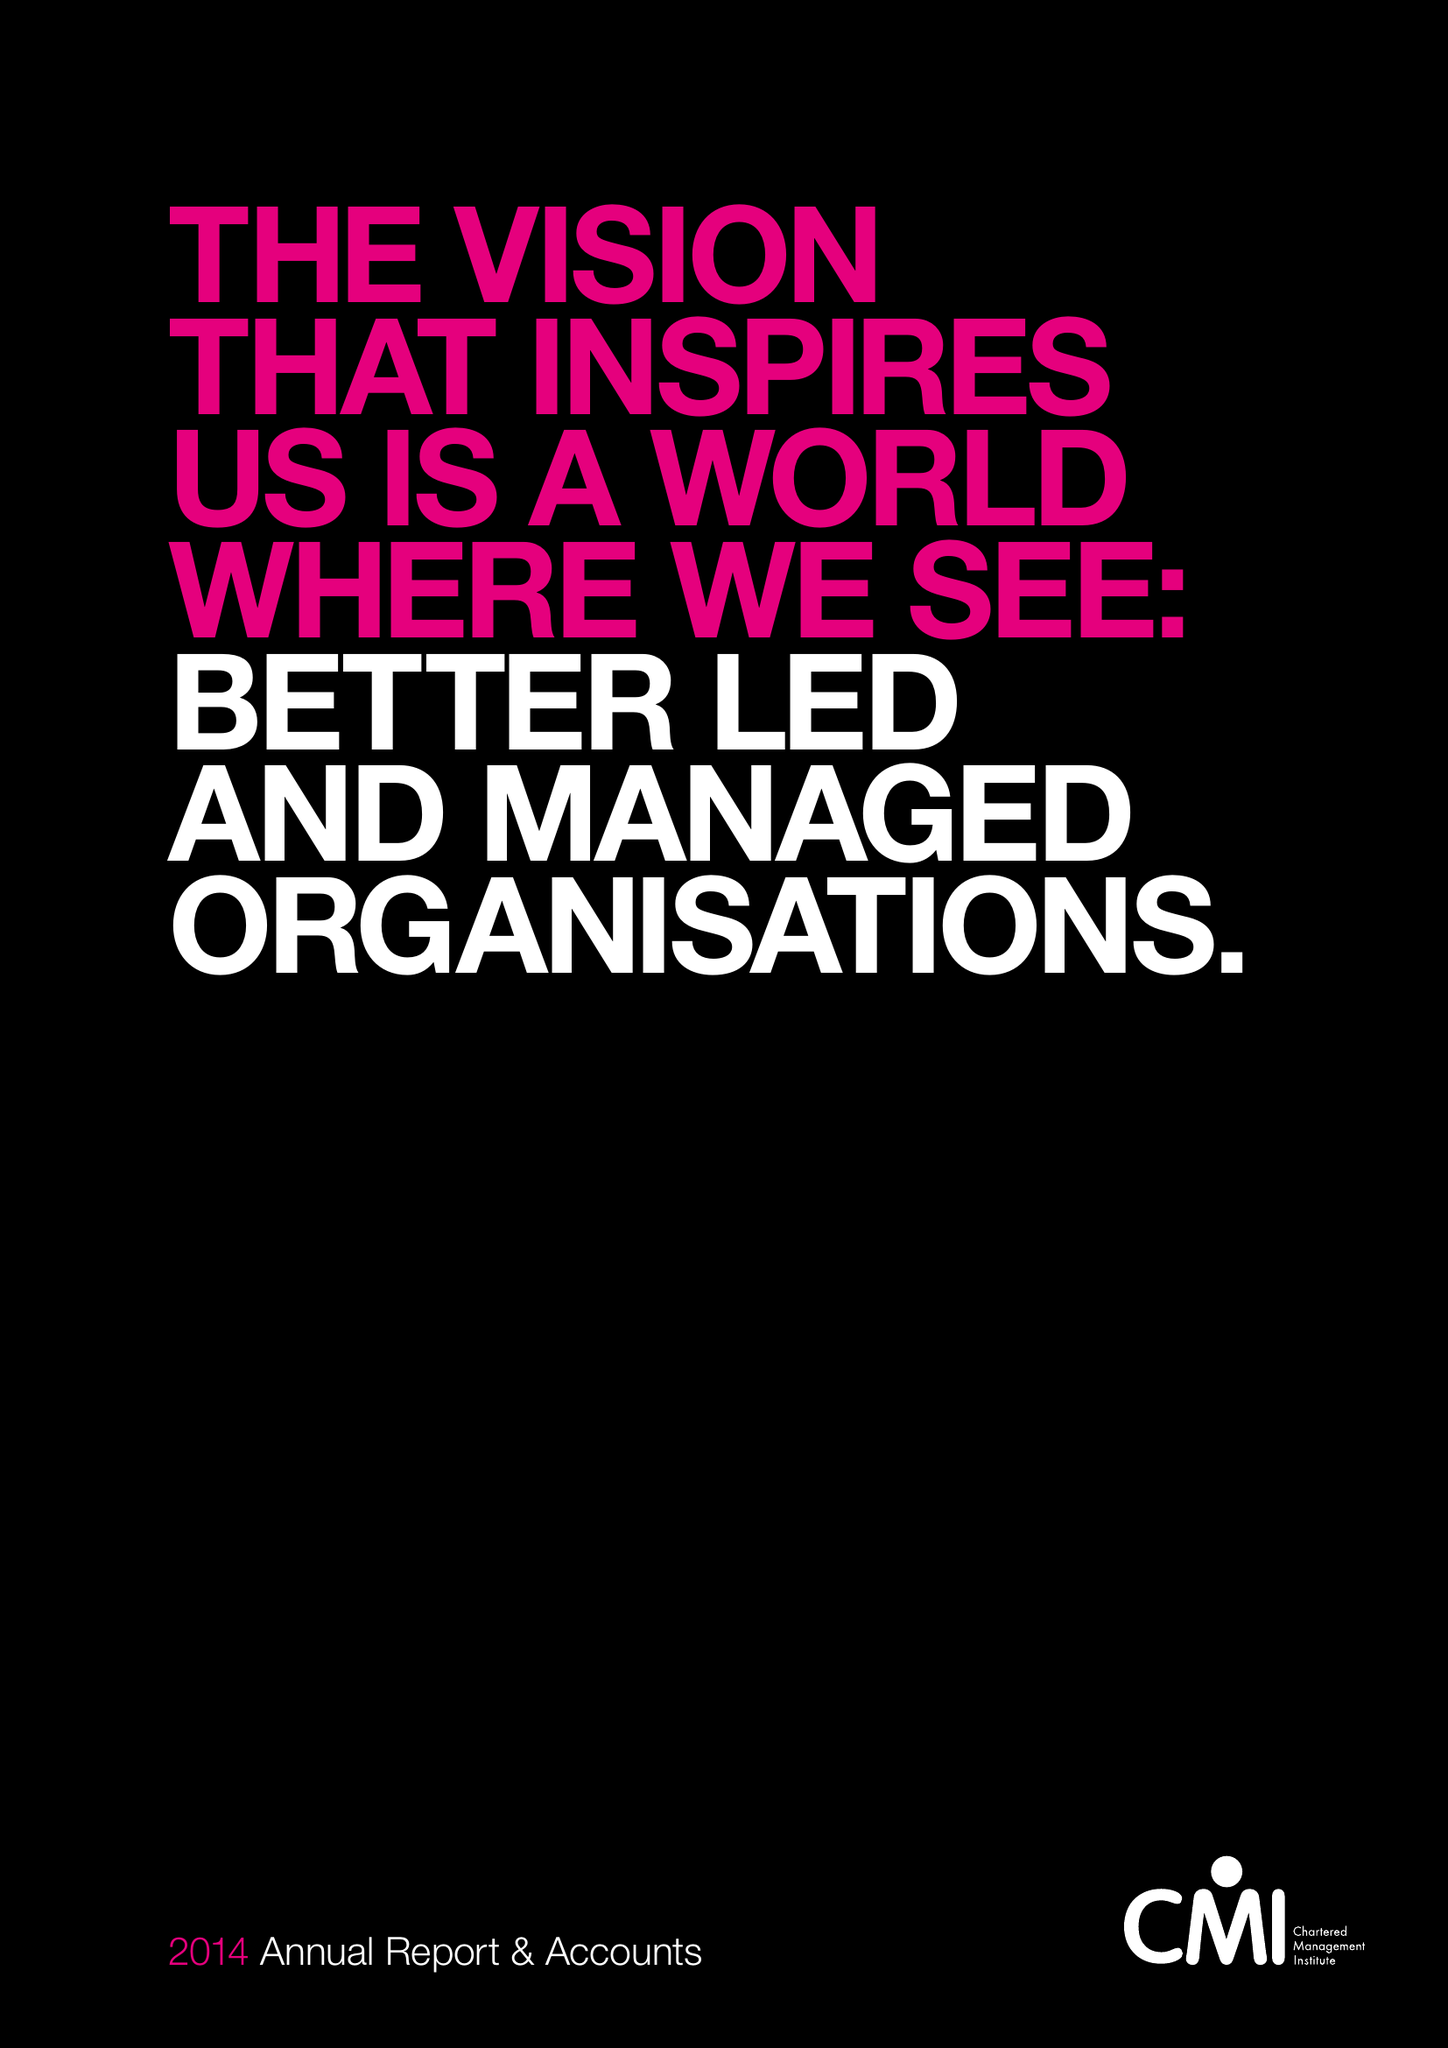What is the value for the address__postcode?
Answer the question using a single word or phrase. NN17 1TT 